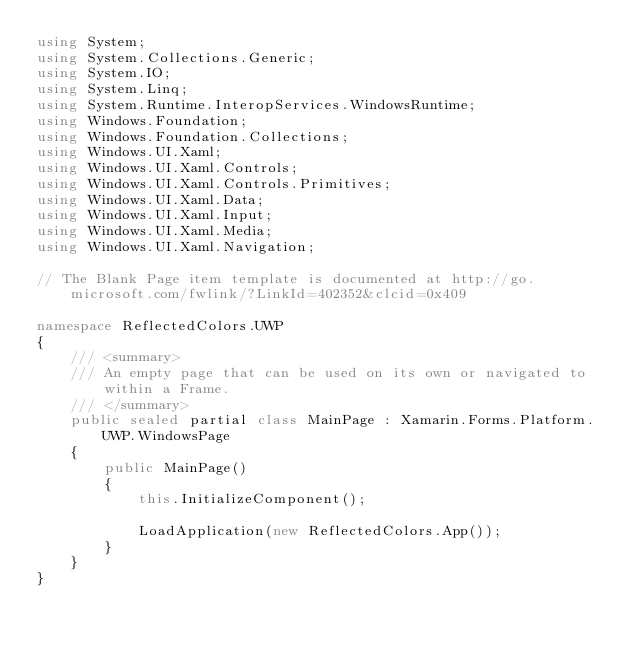<code> <loc_0><loc_0><loc_500><loc_500><_C#_>using System;
using System.Collections.Generic;
using System.IO;
using System.Linq;
using System.Runtime.InteropServices.WindowsRuntime;
using Windows.Foundation;
using Windows.Foundation.Collections;
using Windows.UI.Xaml;
using Windows.UI.Xaml.Controls;
using Windows.UI.Xaml.Controls.Primitives;
using Windows.UI.Xaml.Data;
using Windows.UI.Xaml.Input;
using Windows.UI.Xaml.Media;
using Windows.UI.Xaml.Navigation;

// The Blank Page item template is documented at http://go.microsoft.com/fwlink/?LinkId=402352&clcid=0x409

namespace ReflectedColors.UWP
{
    /// <summary>
    /// An empty page that can be used on its own or navigated to within a Frame.
    /// </summary>
    public sealed partial class MainPage : Xamarin.Forms.Platform.UWP.WindowsPage
    {
        public MainPage()
        {
            this.InitializeComponent();

            LoadApplication(new ReflectedColors.App());
        }
    }
}
</code> 